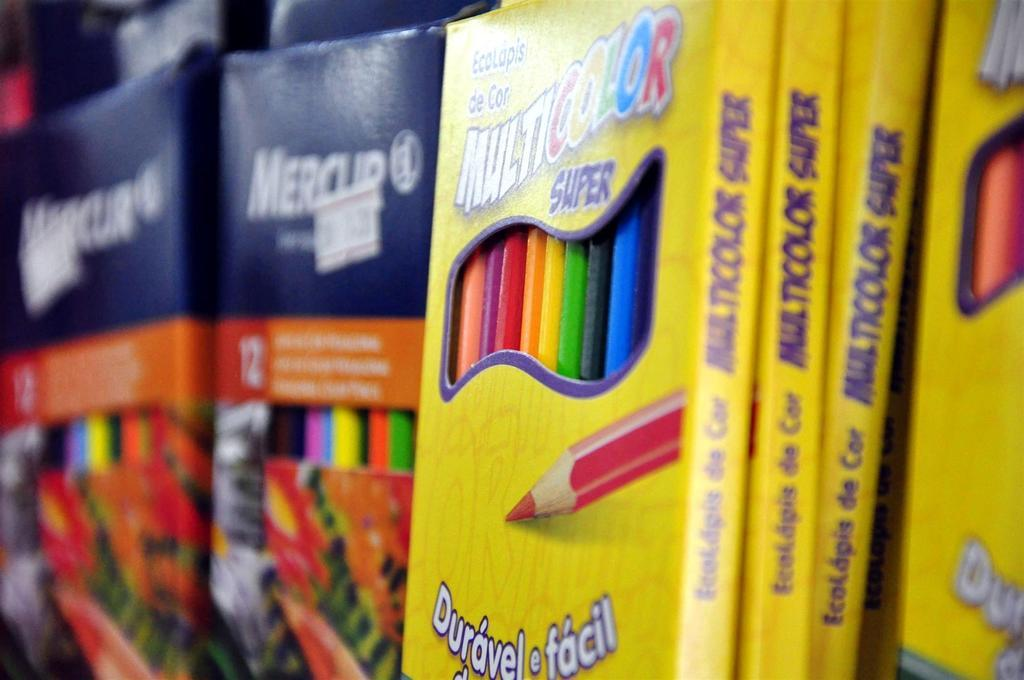<image>
Provide a brief description of the given image. A close up of packs of childrens mutlicolored pencils. 